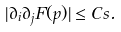<formula> <loc_0><loc_0><loc_500><loc_500>| \partial _ { i } \partial _ { j } F ( p ) | \leq C s .</formula> 